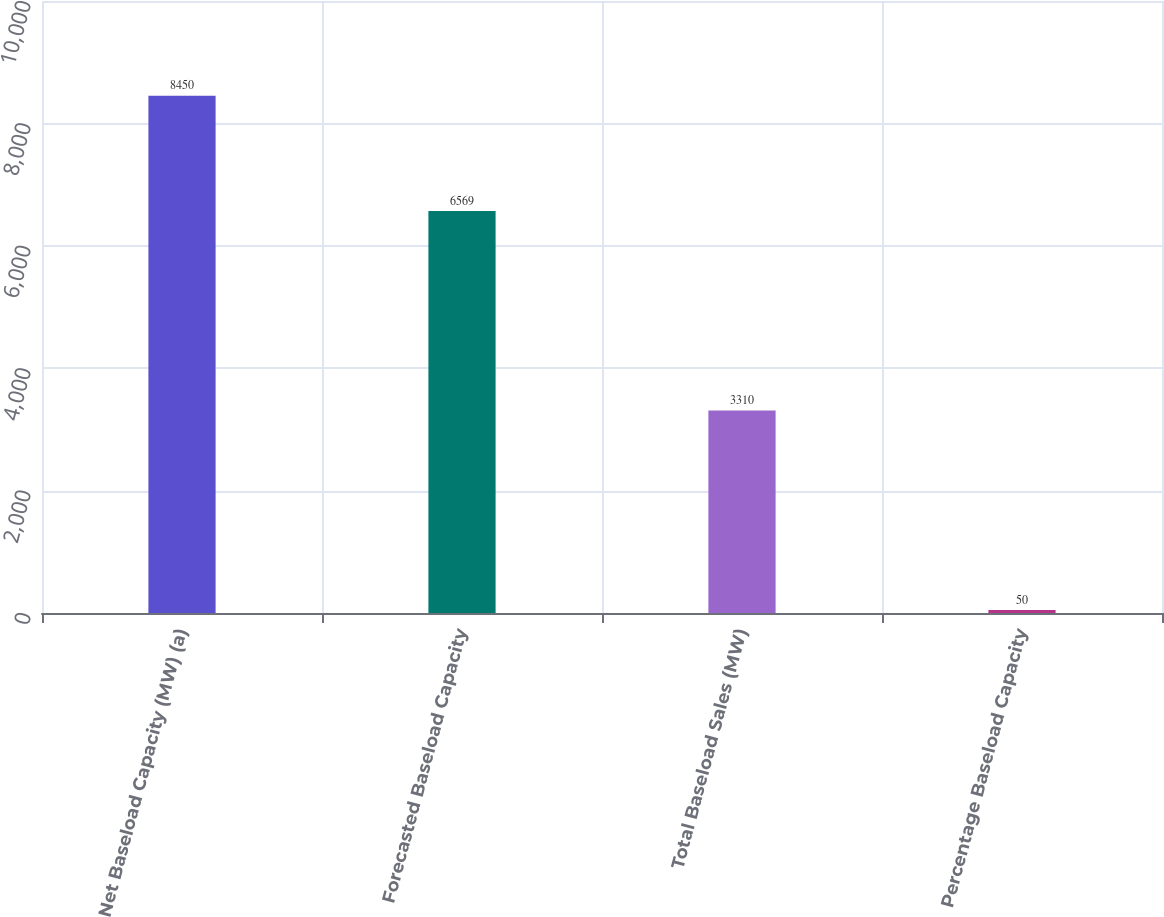<chart> <loc_0><loc_0><loc_500><loc_500><bar_chart><fcel>Net Baseload Capacity (MW) (a)<fcel>Forecasted Baseload Capacity<fcel>Total Baseload Sales (MW)<fcel>Percentage Baseload Capacity<nl><fcel>8450<fcel>6569<fcel>3310<fcel>50<nl></chart> 